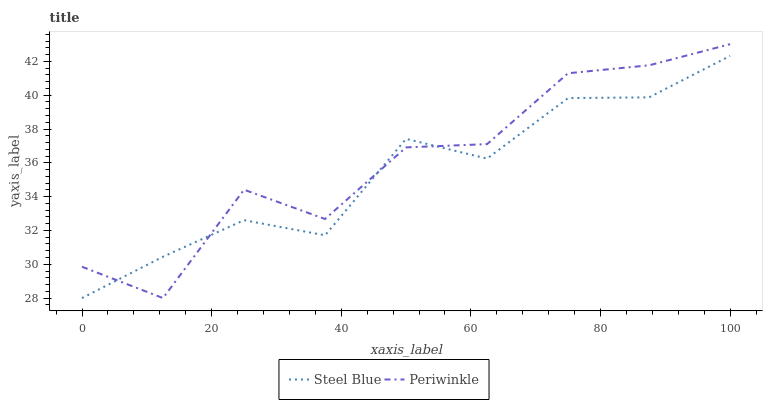Does Steel Blue have the minimum area under the curve?
Answer yes or no. Yes. Does Periwinkle have the maximum area under the curve?
Answer yes or no. Yes. Does Steel Blue have the maximum area under the curve?
Answer yes or no. No. Is Steel Blue the smoothest?
Answer yes or no. Yes. Is Periwinkle the roughest?
Answer yes or no. Yes. Is Steel Blue the roughest?
Answer yes or no. No. Does Periwinkle have the lowest value?
Answer yes or no. Yes. Does Periwinkle have the highest value?
Answer yes or no. Yes. Does Steel Blue have the highest value?
Answer yes or no. No. Does Steel Blue intersect Periwinkle?
Answer yes or no. Yes. Is Steel Blue less than Periwinkle?
Answer yes or no. No. Is Steel Blue greater than Periwinkle?
Answer yes or no. No. 